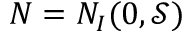<formula> <loc_0><loc_0><loc_500><loc_500>N = N _ { I } ( 0 , { \mathcal { S } } )</formula> 